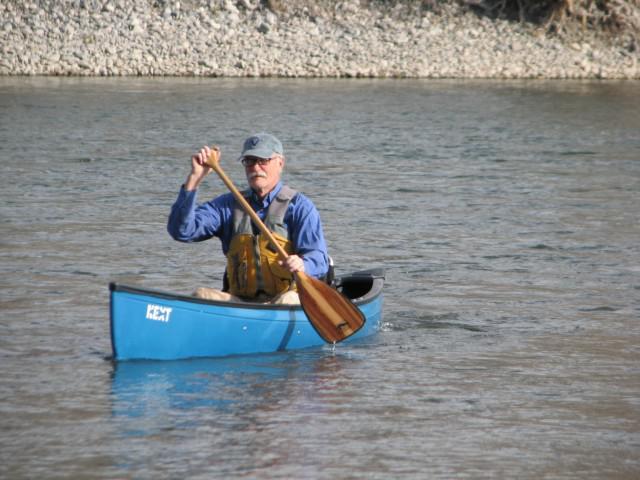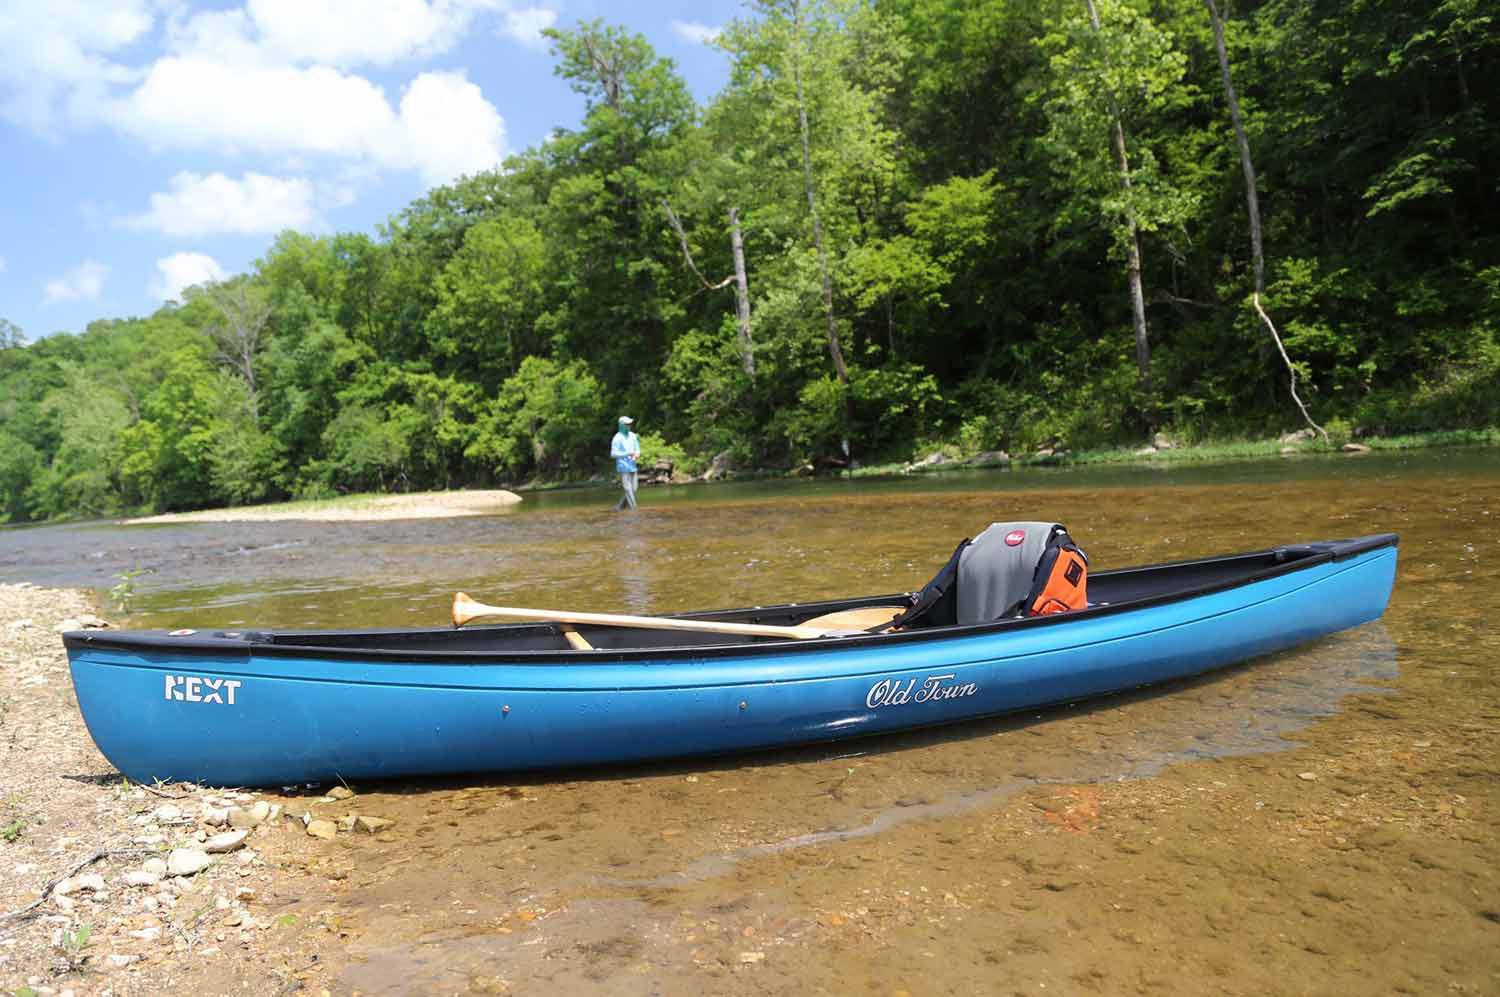The first image is the image on the left, the second image is the image on the right. Considering the images on both sides, is "In one image, a man in a canoe is holding an oar and wearing a life vest and hat." valid? Answer yes or no. Yes. The first image is the image on the left, the second image is the image on the right. Examine the images to the left and right. Is the description "A person is paddling a canoe diagonally to the left in the left image." accurate? Answer yes or no. Yes. 